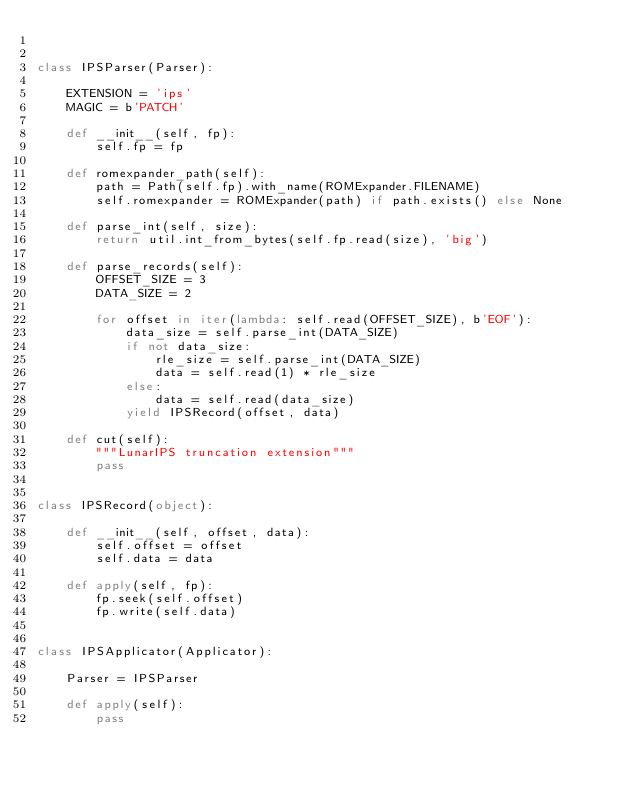Convert code to text. <code><loc_0><loc_0><loc_500><loc_500><_Python_>

class IPSParser(Parser):

    EXTENSION = 'ips'
    MAGIC = b'PATCH'

    def __init__(self, fp):
        self.fp = fp

    def romexpander_path(self):
        path = Path(self.fp).with_name(ROMExpander.FILENAME)
        self.romexpander = ROMExpander(path) if path.exists() else None

    def parse_int(self, size):
        return util.int_from_bytes(self.fp.read(size), 'big')

    def parse_records(self):
        OFFSET_SIZE = 3
        DATA_SIZE = 2

        for offset in iter(lambda: self.read(OFFSET_SIZE), b'EOF'):
            data_size = self.parse_int(DATA_SIZE)
            if not data_size:
                rle_size = self.parse_int(DATA_SIZE)
                data = self.read(1) * rle_size
            else:
                data = self.read(data_size)
            yield IPSRecord(offset, data)

    def cut(self):
        """LunarIPS truncation extension"""
        pass


class IPSRecord(object):

    def __init__(self, offset, data):
        self.offset = offset
        self.data = data

    def apply(self, fp):
        fp.seek(self.offset)
        fp.write(self.data)


class IPSApplicator(Applicator):

    Parser = IPSParser

    def apply(self):
        pass
</code> 